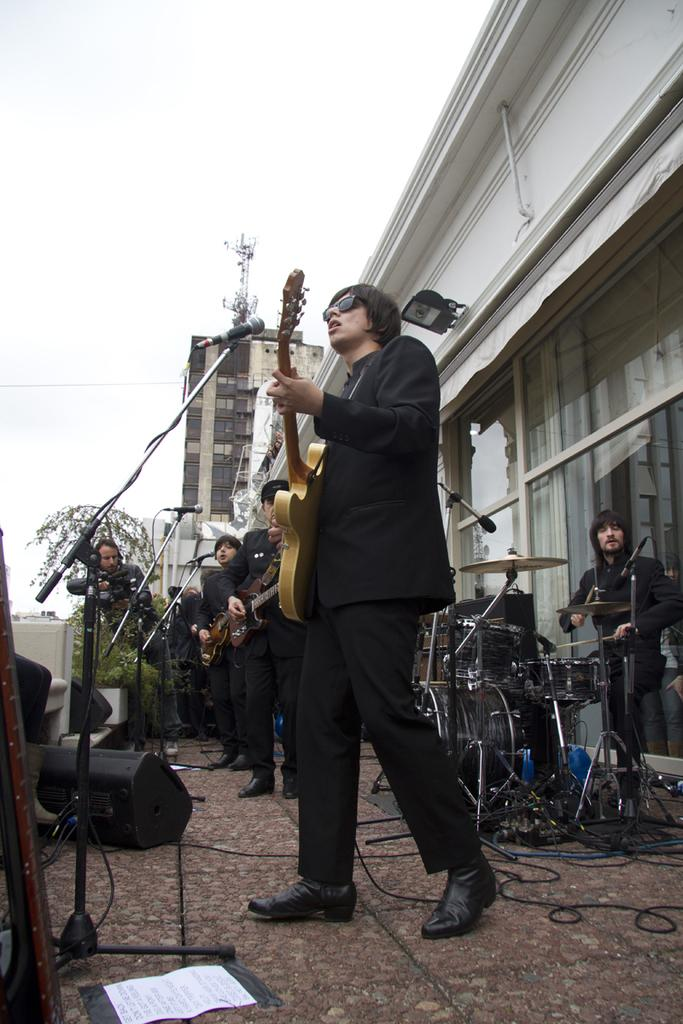How many people are in the image? There are persons in the image. What are the people wearing in the image? The persons are wearing black dresses. What are the people doing in the image? The persons are playing musical instruments. What object can be seen in the image that is used for amplifying sound? There is a microphone in the image. Can you see any sails in the image? There are no sails present in the image. Are the persons in the image pushing a cart? There is no cart or pushing activity depicted in the image. 